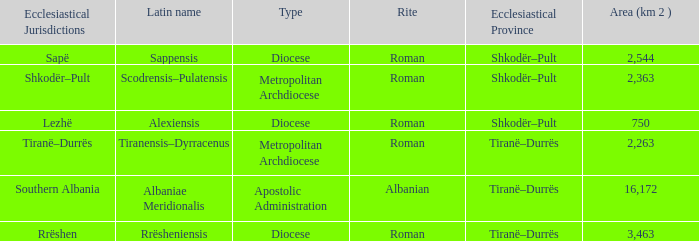What Area (km 2) is lowest with a type being Apostolic Administration? 16172.0. Would you be able to parse every entry in this table? {'header': ['Ecclesiastical Jurisdictions', 'Latin name', 'Type', 'Rite', 'Ecclesiastical Province', 'Area (km 2 )'], 'rows': [['Sapë', 'Sappensis', 'Diocese', 'Roman', 'Shkodër–Pult', '2,544'], ['Shkodër–Pult', 'Scodrensis–Pulatensis', 'Metropolitan Archdiocese', 'Roman', 'Shkodër–Pult', '2,363'], ['Lezhë', 'Alexiensis', 'Diocese', 'Roman', 'Shkodër–Pult', '750'], ['Tiranë–Durrës', 'Tiranensis–Dyrracenus', 'Metropolitan Archdiocese', 'Roman', 'Tiranë–Durrës', '2,263'], ['Southern Albania', 'Albaniae Meridionalis', 'Apostolic Administration', 'Albanian', 'Tiranë–Durrës', '16,172'], ['Rrëshen', 'Rrësheniensis', 'Diocese', 'Roman', 'Tiranë–Durrës', '3,463']]} 